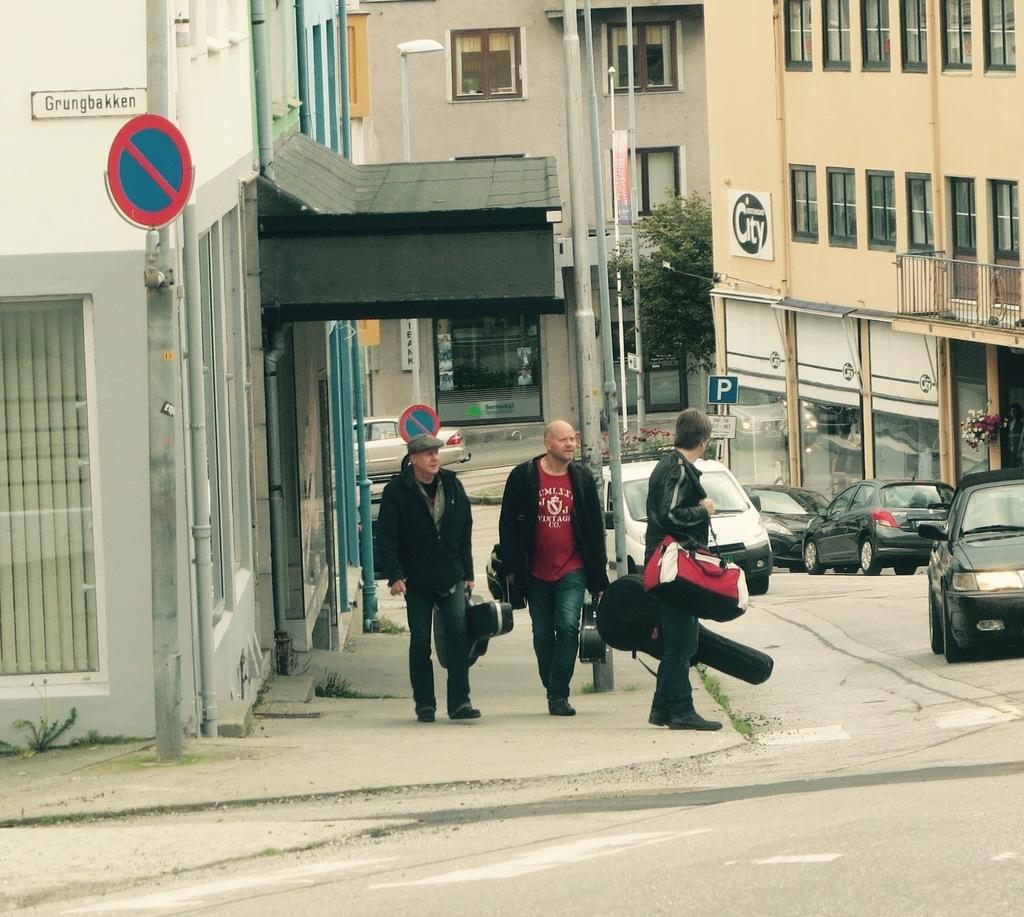<image>
Create a compact narrative representing the image presented. Three musicians walk near a street sign on a building that says Grungbakken. 